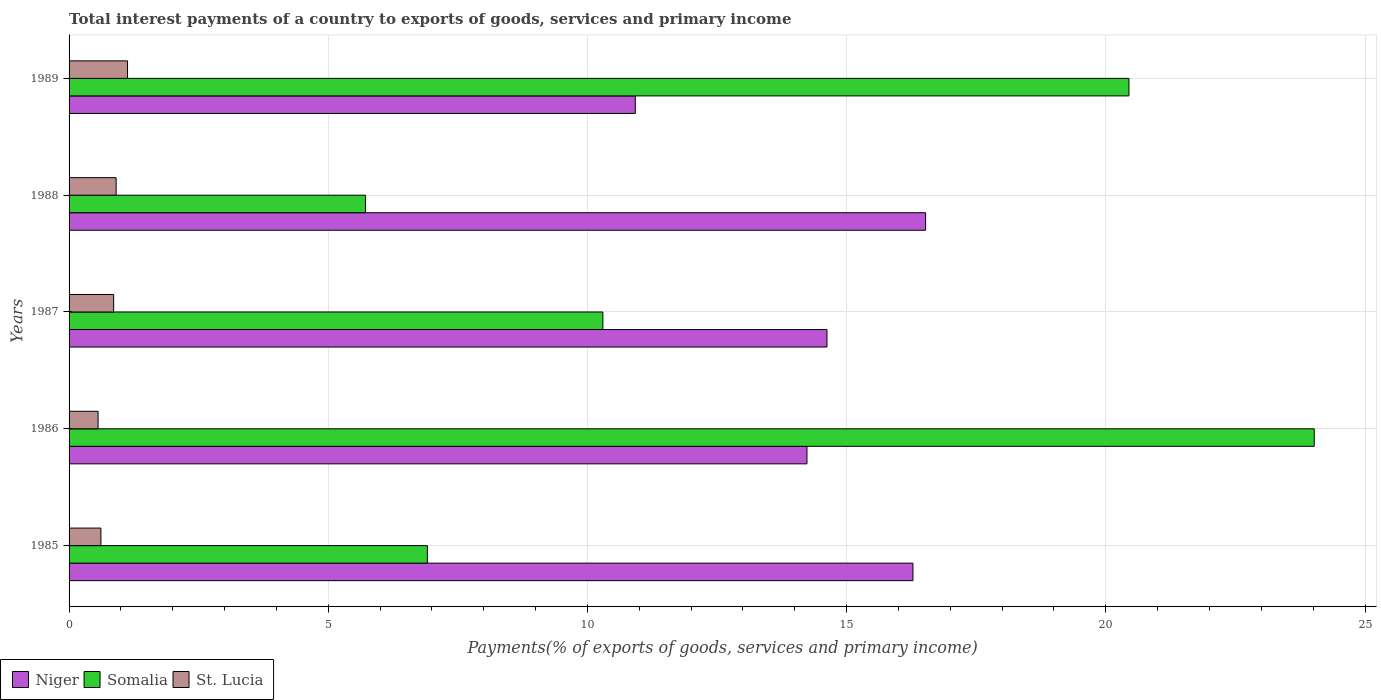How many different coloured bars are there?
Offer a terse response. 3. Are the number of bars on each tick of the Y-axis equal?
Ensure brevity in your answer.  Yes. How many bars are there on the 3rd tick from the top?
Offer a very short reply. 3. What is the label of the 2nd group of bars from the top?
Give a very brief answer. 1988. In how many cases, is the number of bars for a given year not equal to the number of legend labels?
Keep it short and to the point. 0. What is the total interest payments in Niger in 1986?
Ensure brevity in your answer.  14.23. Across all years, what is the maximum total interest payments in Somalia?
Keep it short and to the point. 24.02. Across all years, what is the minimum total interest payments in Somalia?
Offer a very short reply. 5.72. In which year was the total interest payments in St. Lucia maximum?
Give a very brief answer. 1989. In which year was the total interest payments in Somalia minimum?
Give a very brief answer. 1988. What is the total total interest payments in Niger in the graph?
Ensure brevity in your answer.  72.58. What is the difference between the total interest payments in Somalia in 1986 and that in 1987?
Give a very brief answer. 13.72. What is the difference between the total interest payments in Somalia in 1985 and the total interest payments in Niger in 1986?
Your response must be concise. -7.32. What is the average total interest payments in Niger per year?
Your answer should be very brief. 14.52. In the year 1985, what is the difference between the total interest payments in Somalia and total interest payments in St. Lucia?
Offer a very short reply. 6.3. What is the ratio of the total interest payments in Somalia in 1986 to that in 1989?
Give a very brief answer. 1.17. Is the total interest payments in Somalia in 1988 less than that in 1989?
Provide a succinct answer. Yes. Is the difference between the total interest payments in Somalia in 1985 and 1987 greater than the difference between the total interest payments in St. Lucia in 1985 and 1987?
Your answer should be compact. No. What is the difference between the highest and the second highest total interest payments in St. Lucia?
Your answer should be compact. 0.22. What is the difference between the highest and the lowest total interest payments in Niger?
Keep it short and to the point. 5.6. In how many years, is the total interest payments in Somalia greater than the average total interest payments in Somalia taken over all years?
Your answer should be compact. 2. Is the sum of the total interest payments in Somalia in 1985 and 1986 greater than the maximum total interest payments in St. Lucia across all years?
Provide a short and direct response. Yes. What does the 1st bar from the top in 1989 represents?
Your answer should be very brief. St. Lucia. What does the 3rd bar from the bottom in 1989 represents?
Make the answer very short. St. Lucia. How many years are there in the graph?
Your response must be concise. 5. Does the graph contain grids?
Offer a very short reply. Yes. How many legend labels are there?
Provide a short and direct response. 3. What is the title of the graph?
Make the answer very short. Total interest payments of a country to exports of goods, services and primary income. Does "Guam" appear as one of the legend labels in the graph?
Your response must be concise. No. What is the label or title of the X-axis?
Keep it short and to the point. Payments(% of exports of goods, services and primary income). What is the Payments(% of exports of goods, services and primary income) of Niger in 1985?
Provide a short and direct response. 16.28. What is the Payments(% of exports of goods, services and primary income) in Somalia in 1985?
Your answer should be compact. 6.91. What is the Payments(% of exports of goods, services and primary income) in St. Lucia in 1985?
Ensure brevity in your answer.  0.61. What is the Payments(% of exports of goods, services and primary income) of Niger in 1986?
Your answer should be compact. 14.23. What is the Payments(% of exports of goods, services and primary income) in Somalia in 1986?
Offer a very short reply. 24.02. What is the Payments(% of exports of goods, services and primary income) in St. Lucia in 1986?
Offer a terse response. 0.56. What is the Payments(% of exports of goods, services and primary income) in Niger in 1987?
Offer a very short reply. 14.62. What is the Payments(% of exports of goods, services and primary income) in Somalia in 1987?
Provide a short and direct response. 10.3. What is the Payments(% of exports of goods, services and primary income) of St. Lucia in 1987?
Offer a very short reply. 0.86. What is the Payments(% of exports of goods, services and primary income) in Niger in 1988?
Make the answer very short. 16.52. What is the Payments(% of exports of goods, services and primary income) in Somalia in 1988?
Your answer should be compact. 5.72. What is the Payments(% of exports of goods, services and primary income) in St. Lucia in 1988?
Your answer should be very brief. 0.91. What is the Payments(% of exports of goods, services and primary income) of Niger in 1989?
Give a very brief answer. 10.92. What is the Payments(% of exports of goods, services and primary income) of Somalia in 1989?
Give a very brief answer. 20.45. What is the Payments(% of exports of goods, services and primary income) of St. Lucia in 1989?
Provide a short and direct response. 1.13. Across all years, what is the maximum Payments(% of exports of goods, services and primary income) of Niger?
Provide a succinct answer. 16.52. Across all years, what is the maximum Payments(% of exports of goods, services and primary income) of Somalia?
Give a very brief answer. 24.02. Across all years, what is the maximum Payments(% of exports of goods, services and primary income) of St. Lucia?
Ensure brevity in your answer.  1.13. Across all years, what is the minimum Payments(% of exports of goods, services and primary income) of Niger?
Offer a terse response. 10.92. Across all years, what is the minimum Payments(% of exports of goods, services and primary income) of Somalia?
Offer a very short reply. 5.72. Across all years, what is the minimum Payments(% of exports of goods, services and primary income) in St. Lucia?
Offer a very short reply. 0.56. What is the total Payments(% of exports of goods, services and primary income) of Niger in the graph?
Offer a terse response. 72.58. What is the total Payments(% of exports of goods, services and primary income) in Somalia in the graph?
Offer a terse response. 67.39. What is the total Payments(% of exports of goods, services and primary income) in St. Lucia in the graph?
Provide a short and direct response. 4.07. What is the difference between the Payments(% of exports of goods, services and primary income) of Niger in 1985 and that in 1986?
Your answer should be compact. 2.04. What is the difference between the Payments(% of exports of goods, services and primary income) in Somalia in 1985 and that in 1986?
Your response must be concise. -17.11. What is the difference between the Payments(% of exports of goods, services and primary income) of St. Lucia in 1985 and that in 1986?
Your answer should be compact. 0.05. What is the difference between the Payments(% of exports of goods, services and primary income) in Niger in 1985 and that in 1987?
Ensure brevity in your answer.  1.66. What is the difference between the Payments(% of exports of goods, services and primary income) of Somalia in 1985 and that in 1987?
Provide a short and direct response. -3.39. What is the difference between the Payments(% of exports of goods, services and primary income) of St. Lucia in 1985 and that in 1987?
Make the answer very short. -0.25. What is the difference between the Payments(% of exports of goods, services and primary income) in Niger in 1985 and that in 1988?
Provide a succinct answer. -0.24. What is the difference between the Payments(% of exports of goods, services and primary income) of Somalia in 1985 and that in 1988?
Your answer should be compact. 1.19. What is the difference between the Payments(% of exports of goods, services and primary income) of St. Lucia in 1985 and that in 1988?
Your answer should be very brief. -0.29. What is the difference between the Payments(% of exports of goods, services and primary income) in Niger in 1985 and that in 1989?
Provide a succinct answer. 5.36. What is the difference between the Payments(% of exports of goods, services and primary income) in Somalia in 1985 and that in 1989?
Offer a very short reply. -13.53. What is the difference between the Payments(% of exports of goods, services and primary income) of St. Lucia in 1985 and that in 1989?
Give a very brief answer. -0.51. What is the difference between the Payments(% of exports of goods, services and primary income) of Niger in 1986 and that in 1987?
Your answer should be very brief. -0.39. What is the difference between the Payments(% of exports of goods, services and primary income) of Somalia in 1986 and that in 1987?
Ensure brevity in your answer.  13.72. What is the difference between the Payments(% of exports of goods, services and primary income) of St. Lucia in 1986 and that in 1987?
Keep it short and to the point. -0.3. What is the difference between the Payments(% of exports of goods, services and primary income) of Niger in 1986 and that in 1988?
Your response must be concise. -2.29. What is the difference between the Payments(% of exports of goods, services and primary income) in Somalia in 1986 and that in 1988?
Provide a short and direct response. 18.3. What is the difference between the Payments(% of exports of goods, services and primary income) in St. Lucia in 1986 and that in 1988?
Offer a terse response. -0.35. What is the difference between the Payments(% of exports of goods, services and primary income) in Niger in 1986 and that in 1989?
Give a very brief answer. 3.31. What is the difference between the Payments(% of exports of goods, services and primary income) in Somalia in 1986 and that in 1989?
Provide a short and direct response. 3.57. What is the difference between the Payments(% of exports of goods, services and primary income) of St. Lucia in 1986 and that in 1989?
Provide a short and direct response. -0.57. What is the difference between the Payments(% of exports of goods, services and primary income) of Niger in 1987 and that in 1988?
Make the answer very short. -1.9. What is the difference between the Payments(% of exports of goods, services and primary income) of Somalia in 1987 and that in 1988?
Provide a short and direct response. 4.58. What is the difference between the Payments(% of exports of goods, services and primary income) of St. Lucia in 1987 and that in 1988?
Provide a short and direct response. -0.05. What is the difference between the Payments(% of exports of goods, services and primary income) of Niger in 1987 and that in 1989?
Give a very brief answer. 3.7. What is the difference between the Payments(% of exports of goods, services and primary income) of Somalia in 1987 and that in 1989?
Give a very brief answer. -10.15. What is the difference between the Payments(% of exports of goods, services and primary income) of St. Lucia in 1987 and that in 1989?
Your response must be concise. -0.27. What is the difference between the Payments(% of exports of goods, services and primary income) of Niger in 1988 and that in 1989?
Your answer should be very brief. 5.6. What is the difference between the Payments(% of exports of goods, services and primary income) of Somalia in 1988 and that in 1989?
Your answer should be very brief. -14.73. What is the difference between the Payments(% of exports of goods, services and primary income) in St. Lucia in 1988 and that in 1989?
Your answer should be compact. -0.22. What is the difference between the Payments(% of exports of goods, services and primary income) in Niger in 1985 and the Payments(% of exports of goods, services and primary income) in Somalia in 1986?
Your answer should be compact. -7.74. What is the difference between the Payments(% of exports of goods, services and primary income) in Niger in 1985 and the Payments(% of exports of goods, services and primary income) in St. Lucia in 1986?
Offer a terse response. 15.72. What is the difference between the Payments(% of exports of goods, services and primary income) in Somalia in 1985 and the Payments(% of exports of goods, services and primary income) in St. Lucia in 1986?
Ensure brevity in your answer.  6.35. What is the difference between the Payments(% of exports of goods, services and primary income) in Niger in 1985 and the Payments(% of exports of goods, services and primary income) in Somalia in 1987?
Offer a very short reply. 5.98. What is the difference between the Payments(% of exports of goods, services and primary income) in Niger in 1985 and the Payments(% of exports of goods, services and primary income) in St. Lucia in 1987?
Make the answer very short. 15.42. What is the difference between the Payments(% of exports of goods, services and primary income) of Somalia in 1985 and the Payments(% of exports of goods, services and primary income) of St. Lucia in 1987?
Your response must be concise. 6.05. What is the difference between the Payments(% of exports of goods, services and primary income) of Niger in 1985 and the Payments(% of exports of goods, services and primary income) of Somalia in 1988?
Offer a terse response. 10.56. What is the difference between the Payments(% of exports of goods, services and primary income) of Niger in 1985 and the Payments(% of exports of goods, services and primary income) of St. Lucia in 1988?
Your response must be concise. 15.37. What is the difference between the Payments(% of exports of goods, services and primary income) of Somalia in 1985 and the Payments(% of exports of goods, services and primary income) of St. Lucia in 1988?
Give a very brief answer. 6. What is the difference between the Payments(% of exports of goods, services and primary income) in Niger in 1985 and the Payments(% of exports of goods, services and primary income) in Somalia in 1989?
Offer a terse response. -4.17. What is the difference between the Payments(% of exports of goods, services and primary income) of Niger in 1985 and the Payments(% of exports of goods, services and primary income) of St. Lucia in 1989?
Your answer should be compact. 15.15. What is the difference between the Payments(% of exports of goods, services and primary income) of Somalia in 1985 and the Payments(% of exports of goods, services and primary income) of St. Lucia in 1989?
Provide a short and direct response. 5.78. What is the difference between the Payments(% of exports of goods, services and primary income) in Niger in 1986 and the Payments(% of exports of goods, services and primary income) in Somalia in 1987?
Keep it short and to the point. 3.94. What is the difference between the Payments(% of exports of goods, services and primary income) of Niger in 1986 and the Payments(% of exports of goods, services and primary income) of St. Lucia in 1987?
Provide a short and direct response. 13.37. What is the difference between the Payments(% of exports of goods, services and primary income) in Somalia in 1986 and the Payments(% of exports of goods, services and primary income) in St. Lucia in 1987?
Make the answer very short. 23.16. What is the difference between the Payments(% of exports of goods, services and primary income) in Niger in 1986 and the Payments(% of exports of goods, services and primary income) in Somalia in 1988?
Make the answer very short. 8.52. What is the difference between the Payments(% of exports of goods, services and primary income) of Niger in 1986 and the Payments(% of exports of goods, services and primary income) of St. Lucia in 1988?
Provide a short and direct response. 13.33. What is the difference between the Payments(% of exports of goods, services and primary income) in Somalia in 1986 and the Payments(% of exports of goods, services and primary income) in St. Lucia in 1988?
Give a very brief answer. 23.11. What is the difference between the Payments(% of exports of goods, services and primary income) in Niger in 1986 and the Payments(% of exports of goods, services and primary income) in Somalia in 1989?
Make the answer very short. -6.21. What is the difference between the Payments(% of exports of goods, services and primary income) of Niger in 1986 and the Payments(% of exports of goods, services and primary income) of St. Lucia in 1989?
Provide a succinct answer. 13.11. What is the difference between the Payments(% of exports of goods, services and primary income) in Somalia in 1986 and the Payments(% of exports of goods, services and primary income) in St. Lucia in 1989?
Offer a very short reply. 22.89. What is the difference between the Payments(% of exports of goods, services and primary income) of Niger in 1987 and the Payments(% of exports of goods, services and primary income) of Somalia in 1988?
Ensure brevity in your answer.  8.9. What is the difference between the Payments(% of exports of goods, services and primary income) of Niger in 1987 and the Payments(% of exports of goods, services and primary income) of St. Lucia in 1988?
Ensure brevity in your answer.  13.71. What is the difference between the Payments(% of exports of goods, services and primary income) in Somalia in 1987 and the Payments(% of exports of goods, services and primary income) in St. Lucia in 1988?
Ensure brevity in your answer.  9.39. What is the difference between the Payments(% of exports of goods, services and primary income) of Niger in 1987 and the Payments(% of exports of goods, services and primary income) of Somalia in 1989?
Ensure brevity in your answer.  -5.83. What is the difference between the Payments(% of exports of goods, services and primary income) of Niger in 1987 and the Payments(% of exports of goods, services and primary income) of St. Lucia in 1989?
Offer a very short reply. 13.49. What is the difference between the Payments(% of exports of goods, services and primary income) of Somalia in 1987 and the Payments(% of exports of goods, services and primary income) of St. Lucia in 1989?
Give a very brief answer. 9.17. What is the difference between the Payments(% of exports of goods, services and primary income) in Niger in 1988 and the Payments(% of exports of goods, services and primary income) in Somalia in 1989?
Keep it short and to the point. -3.92. What is the difference between the Payments(% of exports of goods, services and primary income) of Niger in 1988 and the Payments(% of exports of goods, services and primary income) of St. Lucia in 1989?
Offer a very short reply. 15.4. What is the difference between the Payments(% of exports of goods, services and primary income) of Somalia in 1988 and the Payments(% of exports of goods, services and primary income) of St. Lucia in 1989?
Provide a succinct answer. 4.59. What is the average Payments(% of exports of goods, services and primary income) of Niger per year?
Your answer should be compact. 14.52. What is the average Payments(% of exports of goods, services and primary income) of Somalia per year?
Your answer should be compact. 13.48. What is the average Payments(% of exports of goods, services and primary income) of St. Lucia per year?
Provide a succinct answer. 0.81. In the year 1985, what is the difference between the Payments(% of exports of goods, services and primary income) in Niger and Payments(% of exports of goods, services and primary income) in Somalia?
Keep it short and to the point. 9.37. In the year 1985, what is the difference between the Payments(% of exports of goods, services and primary income) in Niger and Payments(% of exports of goods, services and primary income) in St. Lucia?
Offer a very short reply. 15.67. In the year 1985, what is the difference between the Payments(% of exports of goods, services and primary income) in Somalia and Payments(% of exports of goods, services and primary income) in St. Lucia?
Your answer should be very brief. 6.3. In the year 1986, what is the difference between the Payments(% of exports of goods, services and primary income) of Niger and Payments(% of exports of goods, services and primary income) of Somalia?
Your answer should be very brief. -9.79. In the year 1986, what is the difference between the Payments(% of exports of goods, services and primary income) of Niger and Payments(% of exports of goods, services and primary income) of St. Lucia?
Keep it short and to the point. 13.68. In the year 1986, what is the difference between the Payments(% of exports of goods, services and primary income) of Somalia and Payments(% of exports of goods, services and primary income) of St. Lucia?
Offer a terse response. 23.46. In the year 1987, what is the difference between the Payments(% of exports of goods, services and primary income) in Niger and Payments(% of exports of goods, services and primary income) in Somalia?
Offer a terse response. 4.32. In the year 1987, what is the difference between the Payments(% of exports of goods, services and primary income) in Niger and Payments(% of exports of goods, services and primary income) in St. Lucia?
Provide a short and direct response. 13.76. In the year 1987, what is the difference between the Payments(% of exports of goods, services and primary income) in Somalia and Payments(% of exports of goods, services and primary income) in St. Lucia?
Provide a short and direct response. 9.44. In the year 1988, what is the difference between the Payments(% of exports of goods, services and primary income) of Niger and Payments(% of exports of goods, services and primary income) of Somalia?
Provide a short and direct response. 10.81. In the year 1988, what is the difference between the Payments(% of exports of goods, services and primary income) of Niger and Payments(% of exports of goods, services and primary income) of St. Lucia?
Keep it short and to the point. 15.62. In the year 1988, what is the difference between the Payments(% of exports of goods, services and primary income) of Somalia and Payments(% of exports of goods, services and primary income) of St. Lucia?
Give a very brief answer. 4.81. In the year 1989, what is the difference between the Payments(% of exports of goods, services and primary income) of Niger and Payments(% of exports of goods, services and primary income) of Somalia?
Your answer should be very brief. -9.52. In the year 1989, what is the difference between the Payments(% of exports of goods, services and primary income) in Niger and Payments(% of exports of goods, services and primary income) in St. Lucia?
Ensure brevity in your answer.  9.8. In the year 1989, what is the difference between the Payments(% of exports of goods, services and primary income) of Somalia and Payments(% of exports of goods, services and primary income) of St. Lucia?
Offer a very short reply. 19.32. What is the ratio of the Payments(% of exports of goods, services and primary income) of Niger in 1985 to that in 1986?
Your answer should be very brief. 1.14. What is the ratio of the Payments(% of exports of goods, services and primary income) in Somalia in 1985 to that in 1986?
Your response must be concise. 0.29. What is the ratio of the Payments(% of exports of goods, services and primary income) of St. Lucia in 1985 to that in 1986?
Provide a short and direct response. 1.1. What is the ratio of the Payments(% of exports of goods, services and primary income) of Niger in 1985 to that in 1987?
Your answer should be very brief. 1.11. What is the ratio of the Payments(% of exports of goods, services and primary income) in Somalia in 1985 to that in 1987?
Make the answer very short. 0.67. What is the ratio of the Payments(% of exports of goods, services and primary income) in St. Lucia in 1985 to that in 1987?
Your answer should be compact. 0.71. What is the ratio of the Payments(% of exports of goods, services and primary income) in Niger in 1985 to that in 1988?
Offer a terse response. 0.99. What is the ratio of the Payments(% of exports of goods, services and primary income) in Somalia in 1985 to that in 1988?
Offer a terse response. 1.21. What is the ratio of the Payments(% of exports of goods, services and primary income) of St. Lucia in 1985 to that in 1988?
Offer a very short reply. 0.68. What is the ratio of the Payments(% of exports of goods, services and primary income) of Niger in 1985 to that in 1989?
Keep it short and to the point. 1.49. What is the ratio of the Payments(% of exports of goods, services and primary income) in Somalia in 1985 to that in 1989?
Keep it short and to the point. 0.34. What is the ratio of the Payments(% of exports of goods, services and primary income) of St. Lucia in 1985 to that in 1989?
Provide a short and direct response. 0.54. What is the ratio of the Payments(% of exports of goods, services and primary income) in Niger in 1986 to that in 1987?
Offer a very short reply. 0.97. What is the ratio of the Payments(% of exports of goods, services and primary income) in Somalia in 1986 to that in 1987?
Keep it short and to the point. 2.33. What is the ratio of the Payments(% of exports of goods, services and primary income) of St. Lucia in 1986 to that in 1987?
Make the answer very short. 0.65. What is the ratio of the Payments(% of exports of goods, services and primary income) in Niger in 1986 to that in 1988?
Offer a very short reply. 0.86. What is the ratio of the Payments(% of exports of goods, services and primary income) of Somalia in 1986 to that in 1988?
Your response must be concise. 4.2. What is the ratio of the Payments(% of exports of goods, services and primary income) in St. Lucia in 1986 to that in 1988?
Provide a short and direct response. 0.62. What is the ratio of the Payments(% of exports of goods, services and primary income) of Niger in 1986 to that in 1989?
Your answer should be very brief. 1.3. What is the ratio of the Payments(% of exports of goods, services and primary income) of Somalia in 1986 to that in 1989?
Provide a short and direct response. 1.17. What is the ratio of the Payments(% of exports of goods, services and primary income) of St. Lucia in 1986 to that in 1989?
Provide a short and direct response. 0.5. What is the ratio of the Payments(% of exports of goods, services and primary income) of Niger in 1987 to that in 1988?
Offer a very short reply. 0.88. What is the ratio of the Payments(% of exports of goods, services and primary income) of Somalia in 1987 to that in 1988?
Give a very brief answer. 1.8. What is the ratio of the Payments(% of exports of goods, services and primary income) of St. Lucia in 1987 to that in 1988?
Keep it short and to the point. 0.95. What is the ratio of the Payments(% of exports of goods, services and primary income) of Niger in 1987 to that in 1989?
Keep it short and to the point. 1.34. What is the ratio of the Payments(% of exports of goods, services and primary income) in Somalia in 1987 to that in 1989?
Ensure brevity in your answer.  0.5. What is the ratio of the Payments(% of exports of goods, services and primary income) in St. Lucia in 1987 to that in 1989?
Your response must be concise. 0.76. What is the ratio of the Payments(% of exports of goods, services and primary income) of Niger in 1988 to that in 1989?
Your response must be concise. 1.51. What is the ratio of the Payments(% of exports of goods, services and primary income) of Somalia in 1988 to that in 1989?
Your response must be concise. 0.28. What is the ratio of the Payments(% of exports of goods, services and primary income) in St. Lucia in 1988 to that in 1989?
Provide a short and direct response. 0.81. What is the difference between the highest and the second highest Payments(% of exports of goods, services and primary income) in Niger?
Ensure brevity in your answer.  0.24. What is the difference between the highest and the second highest Payments(% of exports of goods, services and primary income) in Somalia?
Your response must be concise. 3.57. What is the difference between the highest and the second highest Payments(% of exports of goods, services and primary income) of St. Lucia?
Your answer should be compact. 0.22. What is the difference between the highest and the lowest Payments(% of exports of goods, services and primary income) of Niger?
Give a very brief answer. 5.6. What is the difference between the highest and the lowest Payments(% of exports of goods, services and primary income) of Somalia?
Keep it short and to the point. 18.3. What is the difference between the highest and the lowest Payments(% of exports of goods, services and primary income) in St. Lucia?
Your answer should be very brief. 0.57. 